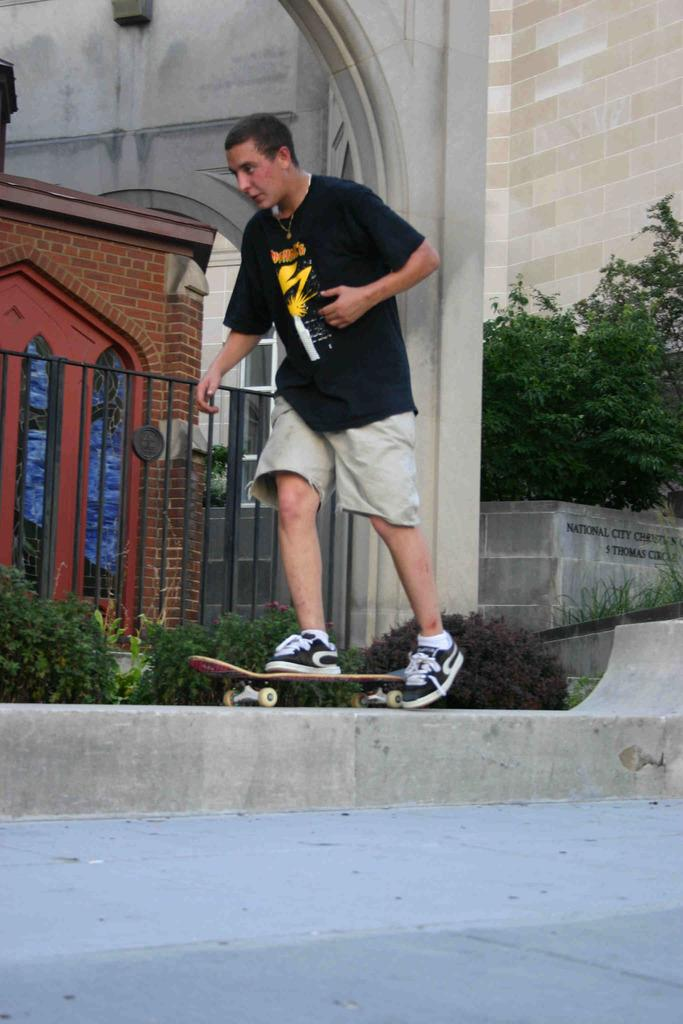What is the man in the image doing? The man is skating on a skateboard. Where is the skateboard located in the image? The skateboard is on a wall. What is at the bottom of the wall? There is a platform at the bottom of the wall. What can be seen in the background of the image? There is a house, a grill, plants, trees, a brick wall, and a pillar in the background of the image. What type of turkey can be seen roasting on the grill in the background of the image? There is no turkey present in the image, nor is there any indication of a grill being used for cooking. 